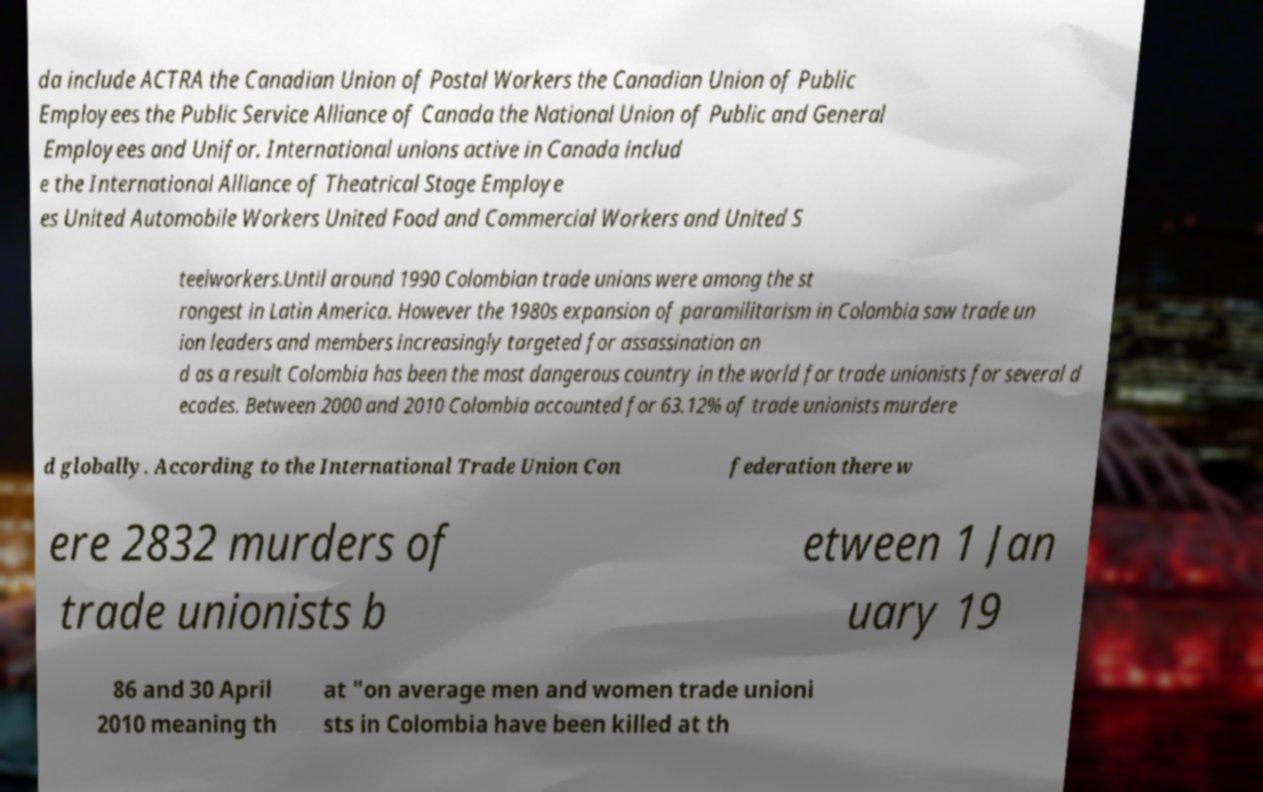Could you extract and type out the text from this image? da include ACTRA the Canadian Union of Postal Workers the Canadian Union of Public Employees the Public Service Alliance of Canada the National Union of Public and General Employees and Unifor. International unions active in Canada includ e the International Alliance of Theatrical Stage Employe es United Automobile Workers United Food and Commercial Workers and United S teelworkers.Until around 1990 Colombian trade unions were among the st rongest in Latin America. However the 1980s expansion of paramilitarism in Colombia saw trade un ion leaders and members increasingly targeted for assassination an d as a result Colombia has been the most dangerous country in the world for trade unionists for several d ecades. Between 2000 and 2010 Colombia accounted for 63.12% of trade unionists murdere d globally. According to the International Trade Union Con federation there w ere 2832 murders of trade unionists b etween 1 Jan uary 19 86 and 30 April 2010 meaning th at "on average men and women trade unioni sts in Colombia have been killed at th 